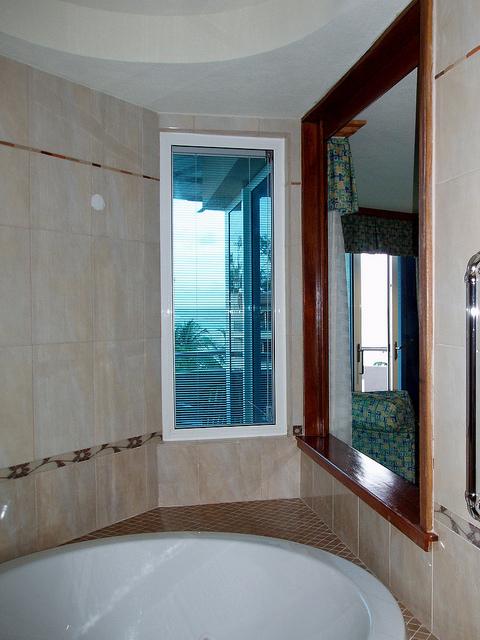What kind of bathtub is this?
Quick response, please. Round. What type of window covering can be seen?
Give a very brief answer. Blinds. What room is this?
Be succinct. Bathroom. 